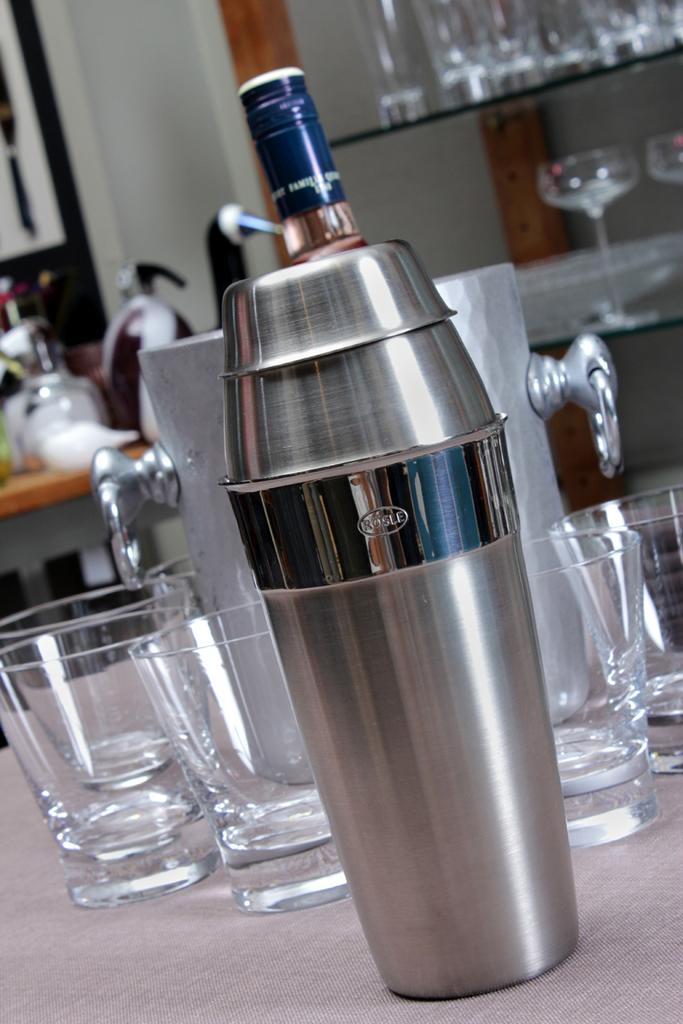What is the name brand of the shaker?
Make the answer very short. Rosle. 